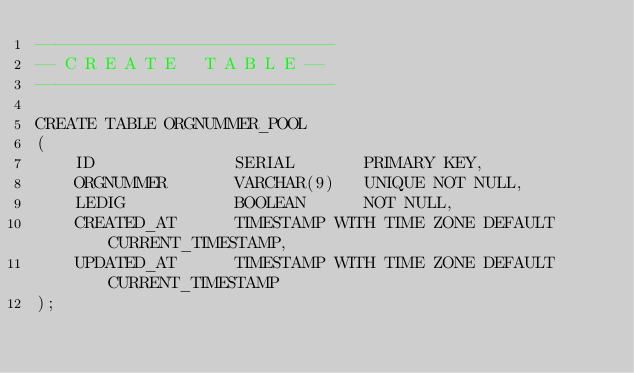Convert code to text. <code><loc_0><loc_0><loc_500><loc_500><_SQL_>------------------------------
-- C R E A T E   T A B L E --
------------------------------

CREATE TABLE ORGNUMMER_POOL
(
    ID              SERIAL       PRIMARY KEY,
    ORGNUMMER       VARCHAR(9)   UNIQUE NOT NULL,
    LEDIG           BOOLEAN      NOT NULL,
    CREATED_AT      TIMESTAMP WITH TIME ZONE DEFAULT CURRENT_TIMESTAMP,
    UPDATED_AT      TIMESTAMP WITH TIME ZONE DEFAULT CURRENT_TIMESTAMP
);</code> 